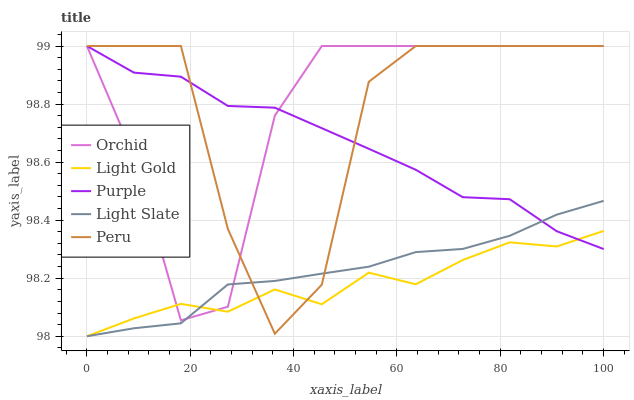Does Light Gold have the minimum area under the curve?
Answer yes or no. Yes. Does Orchid have the maximum area under the curve?
Answer yes or no. Yes. Does Light Slate have the minimum area under the curve?
Answer yes or no. No. Does Light Slate have the maximum area under the curve?
Answer yes or no. No. Is Light Slate the smoothest?
Answer yes or no. Yes. Is Peru the roughest?
Answer yes or no. Yes. Is Light Gold the smoothest?
Answer yes or no. No. Is Light Gold the roughest?
Answer yes or no. No. Does Light Slate have the lowest value?
Answer yes or no. Yes. Does Peru have the lowest value?
Answer yes or no. No. Does Orchid have the highest value?
Answer yes or no. Yes. Does Light Slate have the highest value?
Answer yes or no. No. Does Peru intersect Purple?
Answer yes or no. Yes. Is Peru less than Purple?
Answer yes or no. No. Is Peru greater than Purple?
Answer yes or no. No. 